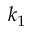Convert formula to latex. <formula><loc_0><loc_0><loc_500><loc_500>k _ { 1 }</formula> 